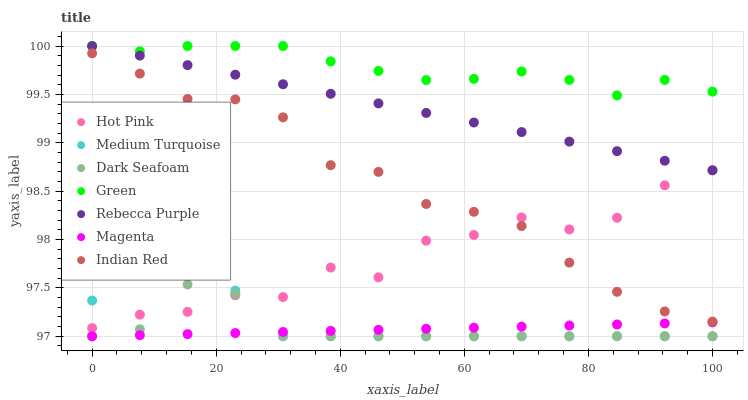Does Magenta have the minimum area under the curve?
Answer yes or no. Yes. Does Green have the maximum area under the curve?
Answer yes or no. Yes. Does Hot Pink have the minimum area under the curve?
Answer yes or no. No. Does Hot Pink have the maximum area under the curve?
Answer yes or no. No. Is Rebecca Purple the smoothest?
Answer yes or no. Yes. Is Hot Pink the roughest?
Answer yes or no. Yes. Is Dark Seafoam the smoothest?
Answer yes or no. No. Is Dark Seafoam the roughest?
Answer yes or no. No. Does Dark Seafoam have the lowest value?
Answer yes or no. Yes. Does Hot Pink have the lowest value?
Answer yes or no. No. Does Rebecca Purple have the highest value?
Answer yes or no. Yes. Does Hot Pink have the highest value?
Answer yes or no. No. Is Magenta less than Rebecca Purple?
Answer yes or no. Yes. Is Rebecca Purple greater than Medium Turquoise?
Answer yes or no. Yes. Does Medium Turquoise intersect Dark Seafoam?
Answer yes or no. Yes. Is Medium Turquoise less than Dark Seafoam?
Answer yes or no. No. Is Medium Turquoise greater than Dark Seafoam?
Answer yes or no. No. Does Magenta intersect Rebecca Purple?
Answer yes or no. No. 